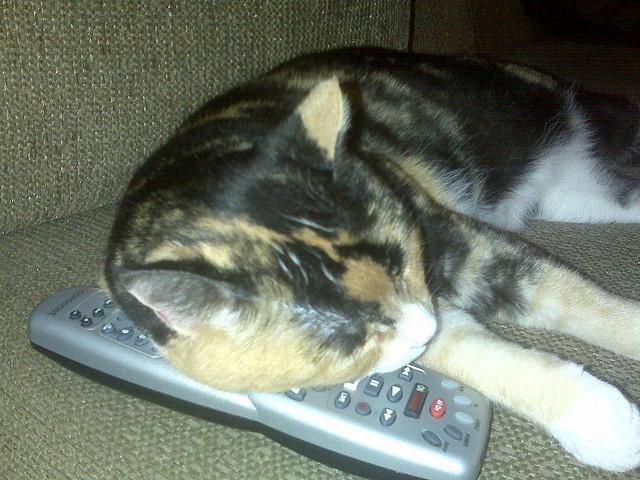Is this a kitten?
Short answer required. Yes. What is the cat resting it's head on?
Concise answer only. Remote. Is the cat sleeping?
Be succinct. Yes. 